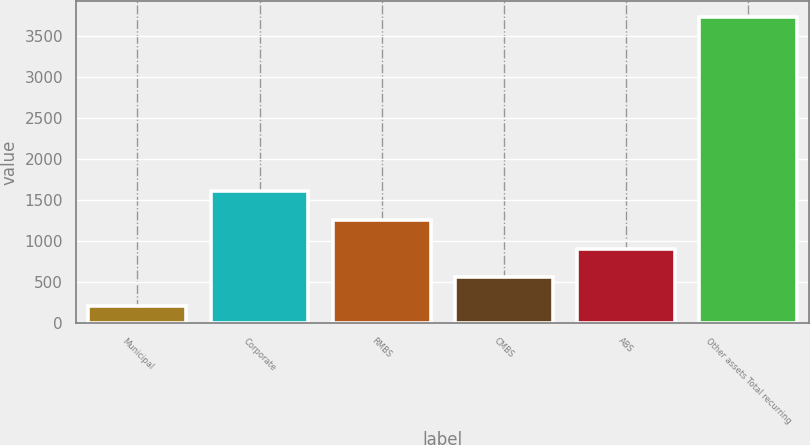Convert chart to OTSL. <chart><loc_0><loc_0><loc_500><loc_500><bar_chart><fcel>Municipal<fcel>Corporate<fcel>RMBS<fcel>CMBS<fcel>ABS<fcel>Other assets Total recurring<nl><fcel>205<fcel>1615.8<fcel>1263.1<fcel>557.7<fcel>910.4<fcel>3732<nl></chart> 